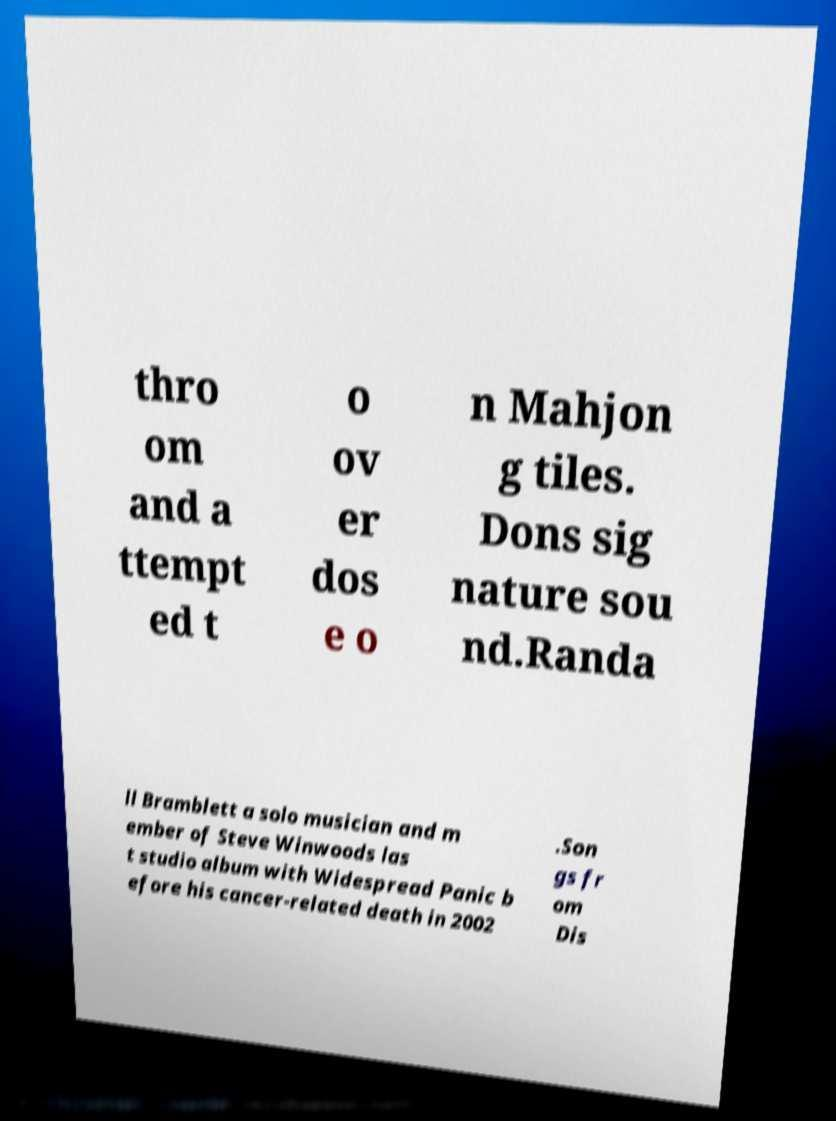There's text embedded in this image that I need extracted. Can you transcribe it verbatim? thro om and a ttempt ed t o ov er dos e o n Mahjon g tiles. Dons sig nature sou nd.Randa ll Bramblett a solo musician and m ember of Steve Winwoods las t studio album with Widespread Panic b efore his cancer-related death in 2002 .Son gs fr om Dis 